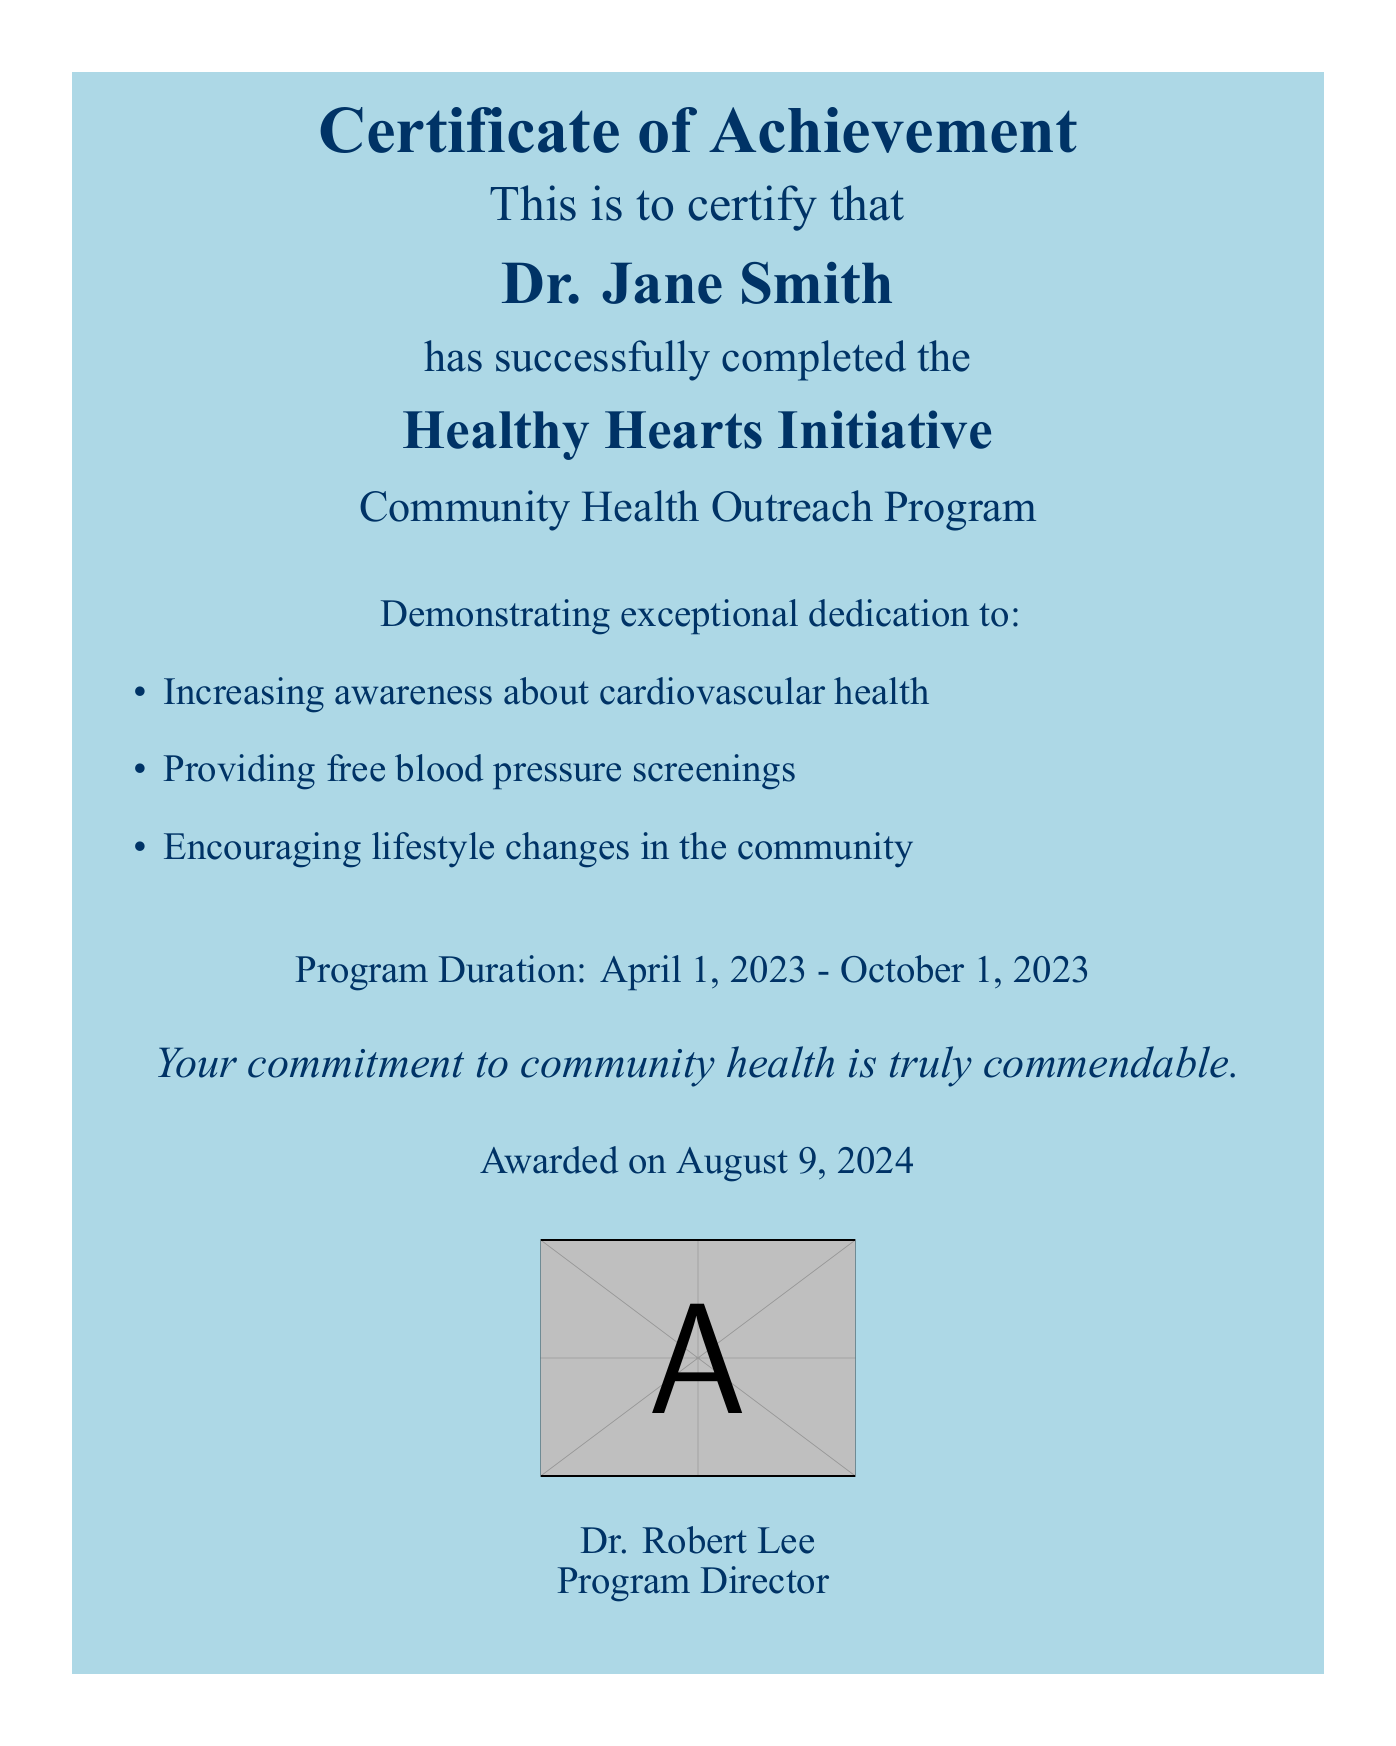What is the title of the program completed? The title of the program completed is stated at the top of the document.
Answer: Healthy Hearts Initiative Who is the recipient of the certificate? The recipient's name is prominently displayed in the document.
Answer: Dr. Jane Smith What is the duration of the program? The program duration is mentioned clearly in the document.
Answer: April 1, 2023 - October 1, 2023 Who awarded the certificate? The name of the person who awarded the certificate is mentioned at the bottom of the document.
Answer: Dr. Robert Lee What is one of the objectives of the program? The objectives are listed as bullet points in the document.
Answer: Increasing awareness about cardiovascular health What type of document is this? The nature of the document is indicated by its title at the top.
Answer: Certificate of Achievement How many activities are listed under the dedication section? The number of items can be counted from the bullet points in the document.
Answer: Three What color is the background of the certificate's title? The background color for the title section is described.
Answer: Light blue What is the font used in the document? The specific font for the document is mentioned in the code.
Answer: Times New Roman 